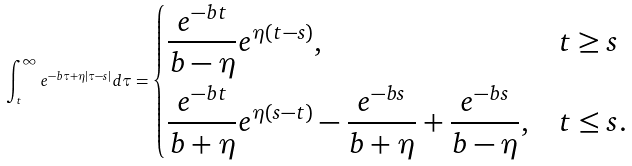Convert formula to latex. <formula><loc_0><loc_0><loc_500><loc_500>\int _ { t } ^ { \infty } e ^ { - b \tau + \eta | \tau - s | } d \tau = \begin{dcases} \frac { e ^ { - b t } } { b - \eta } e ^ { \eta ( t - s ) } , & t \geq s \\ \frac { e ^ { - b t } } { b + \eta } e ^ { \eta ( s - t ) } - \frac { e ^ { - b s } } { b + \eta } + \frac { e ^ { - b s } } { b - \eta } , & t \leq s . \end{dcases}</formula> 